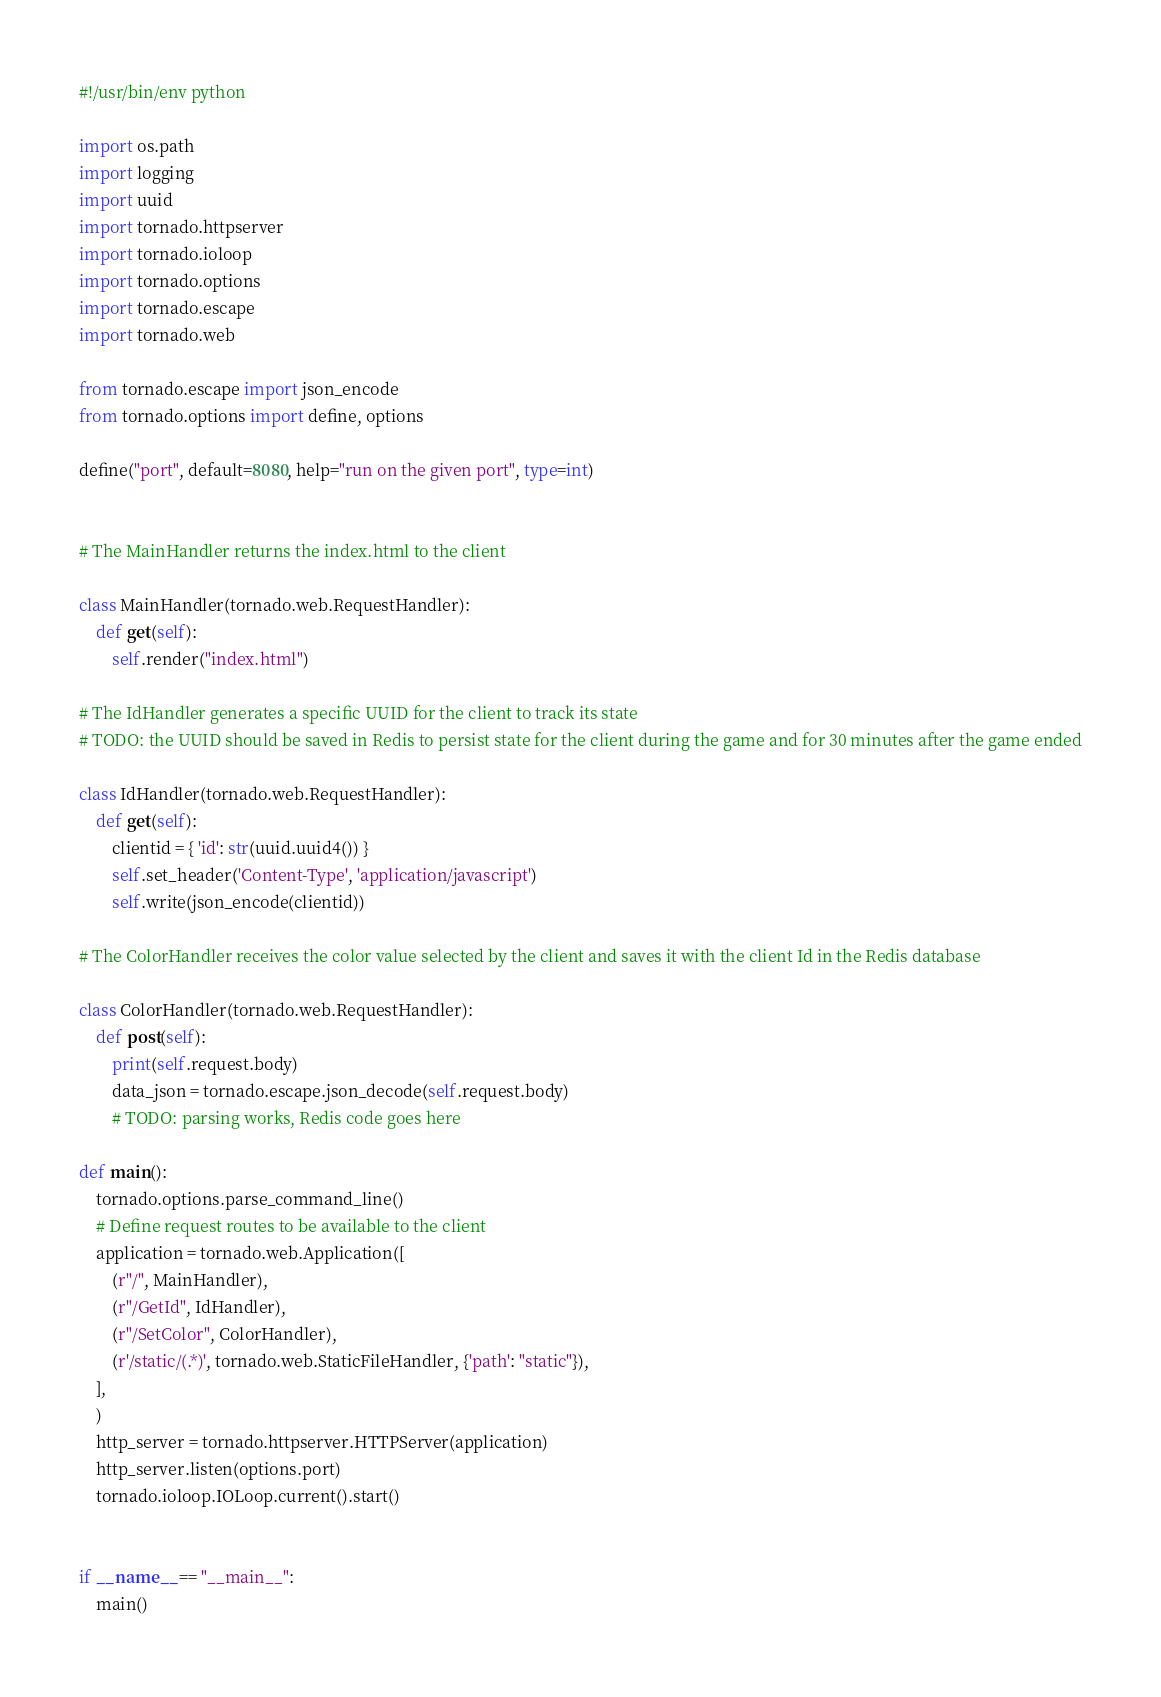Convert code to text. <code><loc_0><loc_0><loc_500><loc_500><_Python_>#!/usr/bin/env python

import os.path
import logging
import uuid
import tornado.httpserver
import tornado.ioloop
import tornado.options
import tornado.escape
import tornado.web

from tornado.escape import json_encode
from tornado.options import define, options

define("port", default=8080, help="run on the given port", type=int)


# The MainHandler returns the index.html to the client

class MainHandler(tornado.web.RequestHandler):
    def get(self):
        self.render("index.html")

# The IdHandler generates a specific UUID for the client to track its state
# TODO: the UUID should be saved in Redis to persist state for the client during the game and for 30 minutes after the game ended

class IdHandler(tornado.web.RequestHandler):
    def get(self):
        clientid = { 'id': str(uuid.uuid4()) }
        self.set_header('Content-Type', 'application/javascript')
        self.write(json_encode(clientid))

# The ColorHandler receives the color value selected by the client and saves it with the client Id in the Redis database

class ColorHandler(tornado.web.RequestHandler):
    def post(self):
        print(self.request.body)
        data_json = tornado.escape.json_decode(self.request.body)
        # TODO: parsing works, Redis code goes here

def main():
    tornado.options.parse_command_line()
    # Define request routes to be available to the client
    application = tornado.web.Application([
        (r"/", MainHandler),
        (r"/GetId", IdHandler),
        (r"/SetColor", ColorHandler),
        (r'/static/(.*)', tornado.web.StaticFileHandler, {'path': "static"}),
    ],
    )
    http_server = tornado.httpserver.HTTPServer(application)
    http_server.listen(options.port)
    tornado.ioloop.IOLoop.current().start()


if __name__ == "__main__":
    main()

</code> 